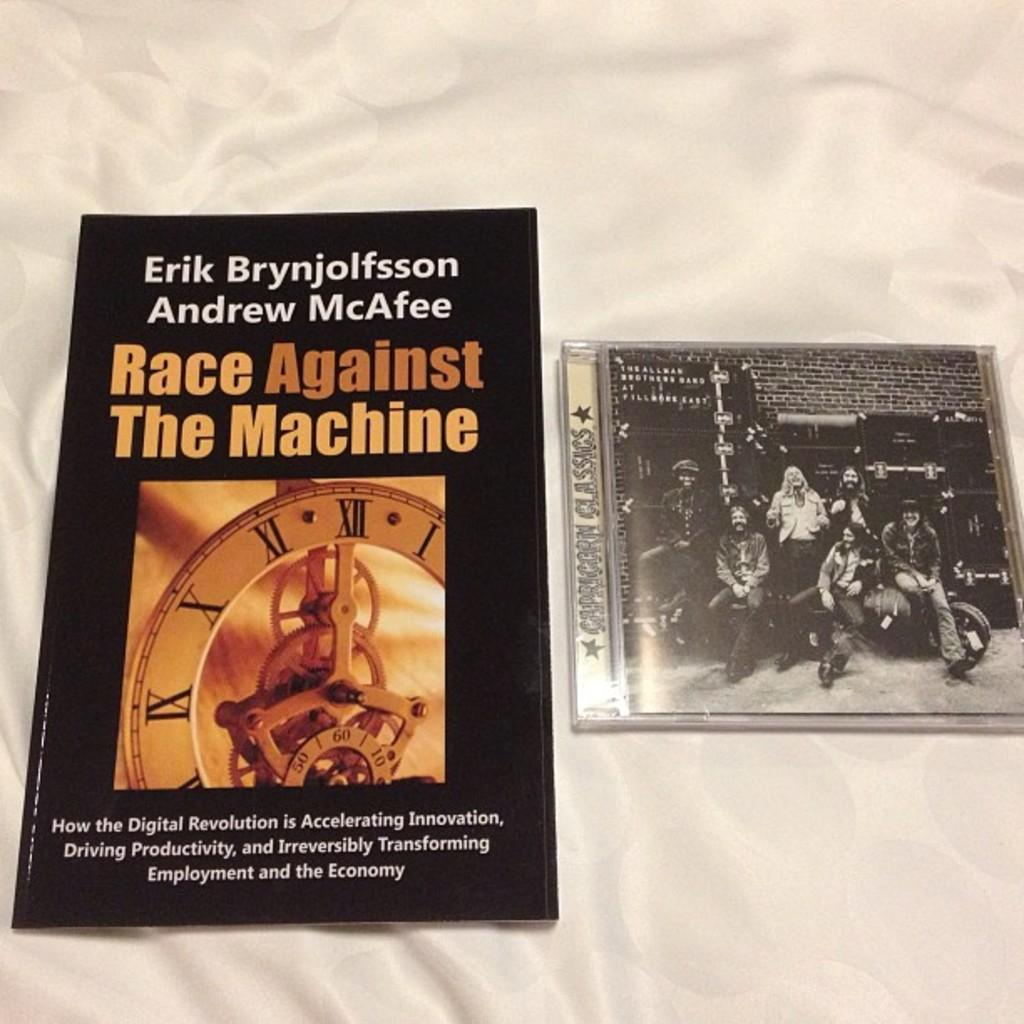Provide a one-sentence caption for the provided image. A book is next to an Allman Brothers Band CD. 